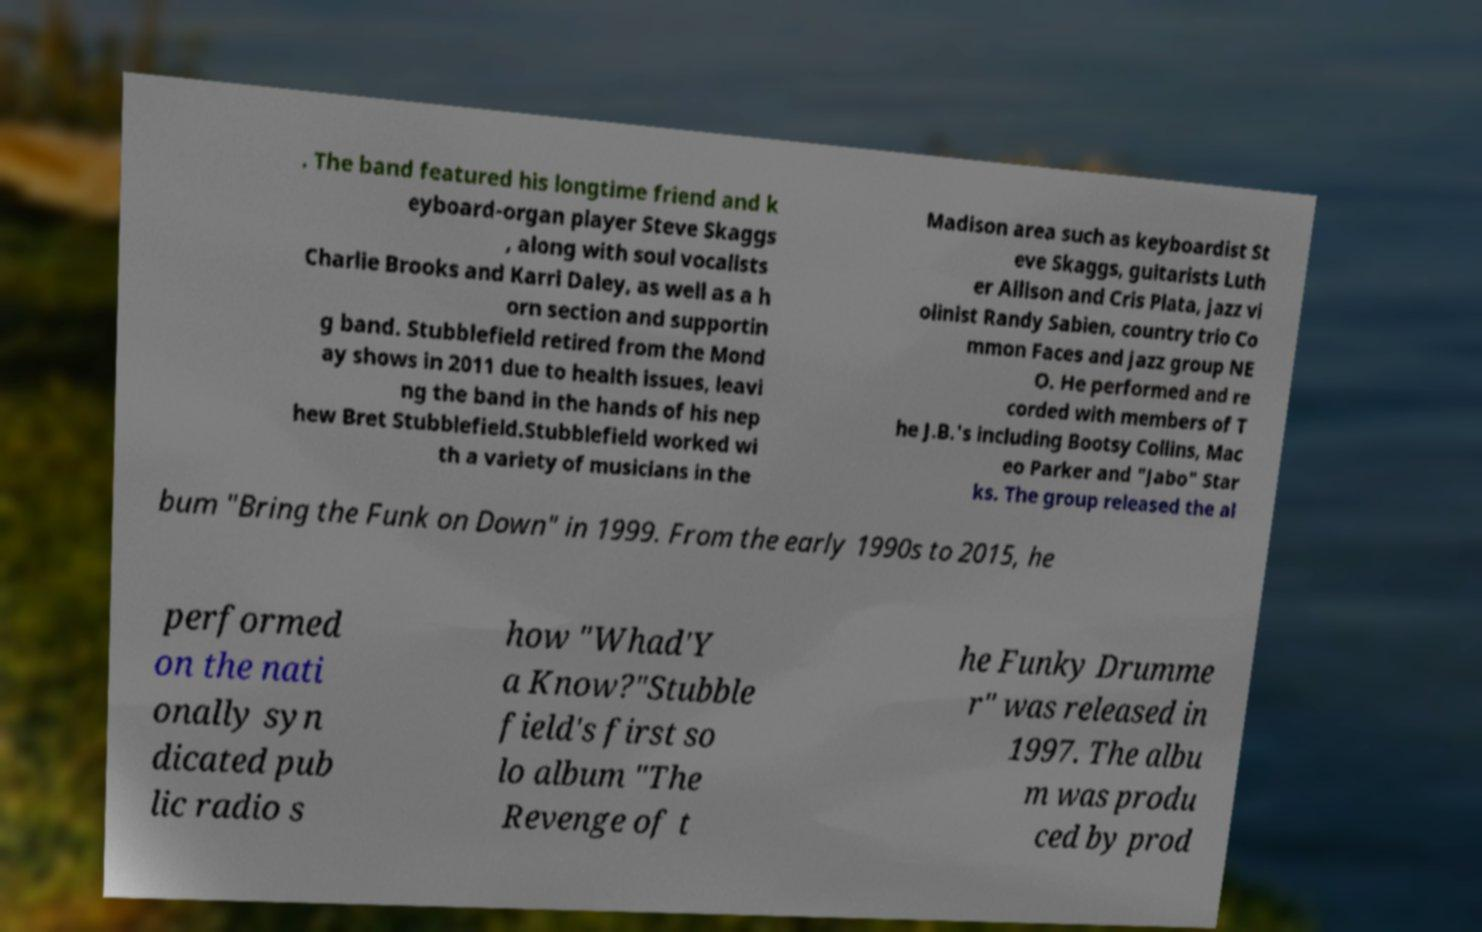Can you accurately transcribe the text from the provided image for me? . The band featured his longtime friend and k eyboard-organ player Steve Skaggs , along with soul vocalists Charlie Brooks and Karri Daley, as well as a h orn section and supportin g band. Stubblefield retired from the Mond ay shows in 2011 due to health issues, leavi ng the band in the hands of his nep hew Bret Stubblefield.Stubblefield worked wi th a variety of musicians in the Madison area such as keyboardist St eve Skaggs, guitarists Luth er Allison and Cris Plata, jazz vi olinist Randy Sabien, country trio Co mmon Faces and jazz group NE O. He performed and re corded with members of T he J.B.'s including Bootsy Collins, Mac eo Parker and "Jabo" Star ks. The group released the al bum "Bring the Funk on Down" in 1999. From the early 1990s to 2015, he performed on the nati onally syn dicated pub lic radio s how "Whad'Y a Know?"Stubble field's first so lo album "The Revenge of t he Funky Drumme r" was released in 1997. The albu m was produ ced by prod 